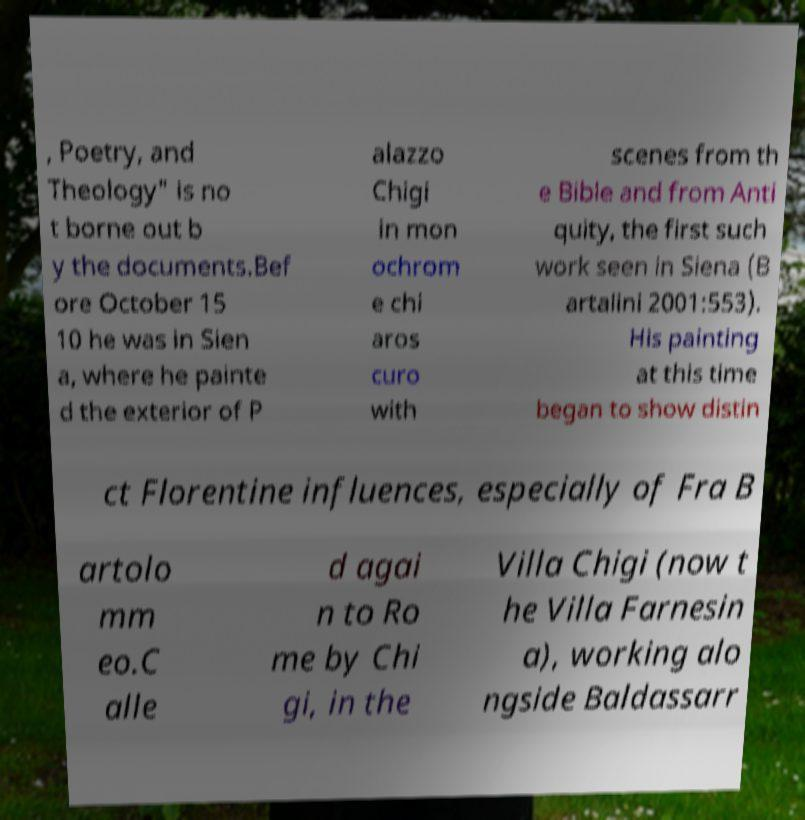There's text embedded in this image that I need extracted. Can you transcribe it verbatim? , Poetry, and Theology" is no t borne out b y the documents.Bef ore October 15 10 he was in Sien a, where he painte d the exterior of P alazzo Chigi in mon ochrom e chi aros curo with scenes from th e Bible and from Anti quity, the first such work seen in Siena (B artalini 2001:553). His painting at this time began to show distin ct Florentine influences, especially of Fra B artolo mm eo.C alle d agai n to Ro me by Chi gi, in the Villa Chigi (now t he Villa Farnesin a), working alo ngside Baldassarr 